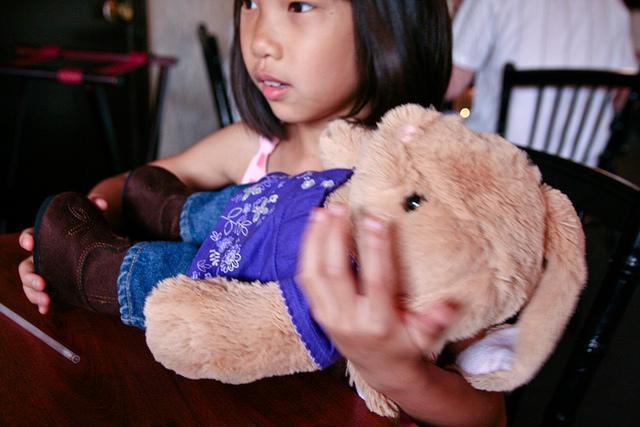Is the caption "The teddy bear is perpendicular to the dining table." a true representation of the image?
Answer yes or no. No. 